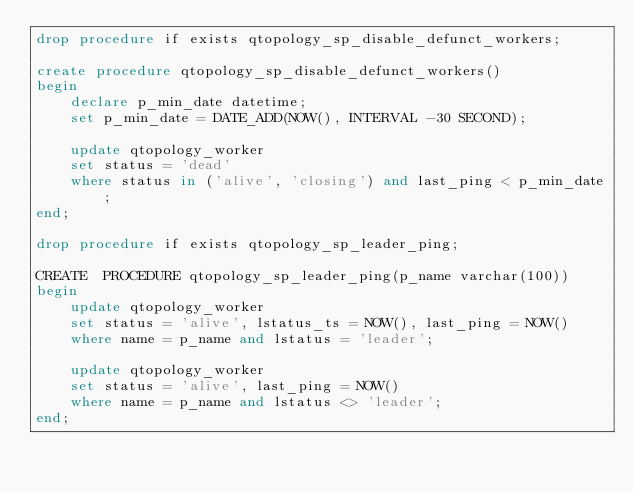<code> <loc_0><loc_0><loc_500><loc_500><_SQL_>drop procedure if exists qtopology_sp_disable_defunct_workers;

create procedure qtopology_sp_disable_defunct_workers()
begin
    declare p_min_date datetime;
    set p_min_date = DATE_ADD(NOW(), INTERVAL -30 SECOND);

    update qtopology_worker
    set status = 'dead'
    where status in ('alive', 'closing') and last_ping < p_min_date;    
end;

drop procedure if exists qtopology_sp_leader_ping;

CREATE  PROCEDURE qtopology_sp_leader_ping(p_name varchar(100))
begin
    update qtopology_worker
    set status = 'alive', lstatus_ts = NOW(), last_ping = NOW()
    where name = p_name and lstatus = 'leader';
    
    update qtopology_worker
    set status = 'alive', last_ping = NOW()
    where name = p_name and lstatus <> 'leader';
end;
</code> 